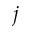Convert formula to latex. <formula><loc_0><loc_0><loc_500><loc_500>j</formula> 